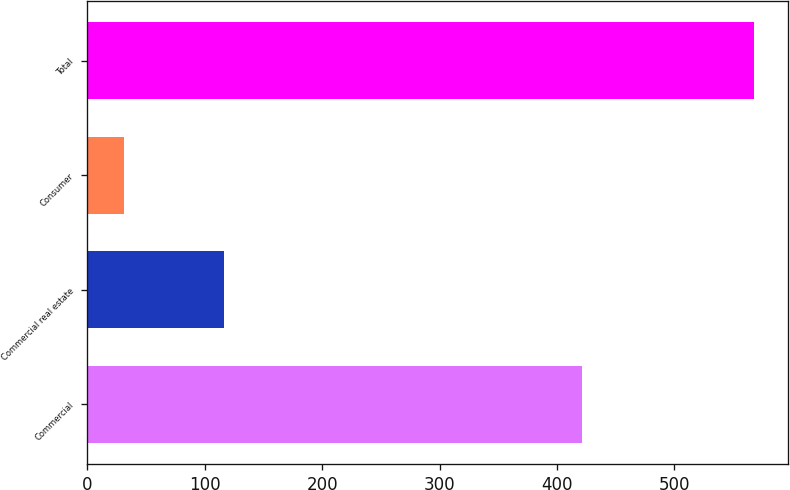<chart> <loc_0><loc_0><loc_500><loc_500><bar_chart><fcel>Commercial<fcel>Commercial real estate<fcel>Consumer<fcel>Total<nl><fcel>421<fcel>116<fcel>31<fcel>568<nl></chart> 